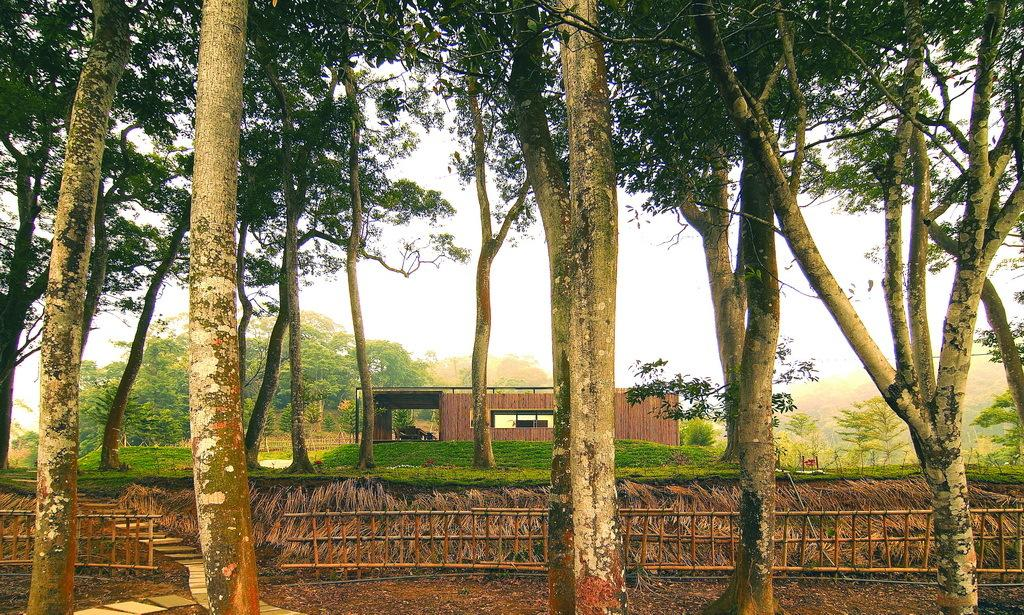What type of structure is visible in the image? There is a house in the image. What other natural elements can be seen in the image? There are plants, trees, and the sky visible in the image. What might be used to enclose or separate areas in the image? There is a fence in the image. What type of chain is being used by the committee in the image? There is no chain or committee present in the image. How many spiders can be seen crawling on the house in the image? There are no spiders visible in the image; it features a house, plants, trees, a fence, and the sky. 